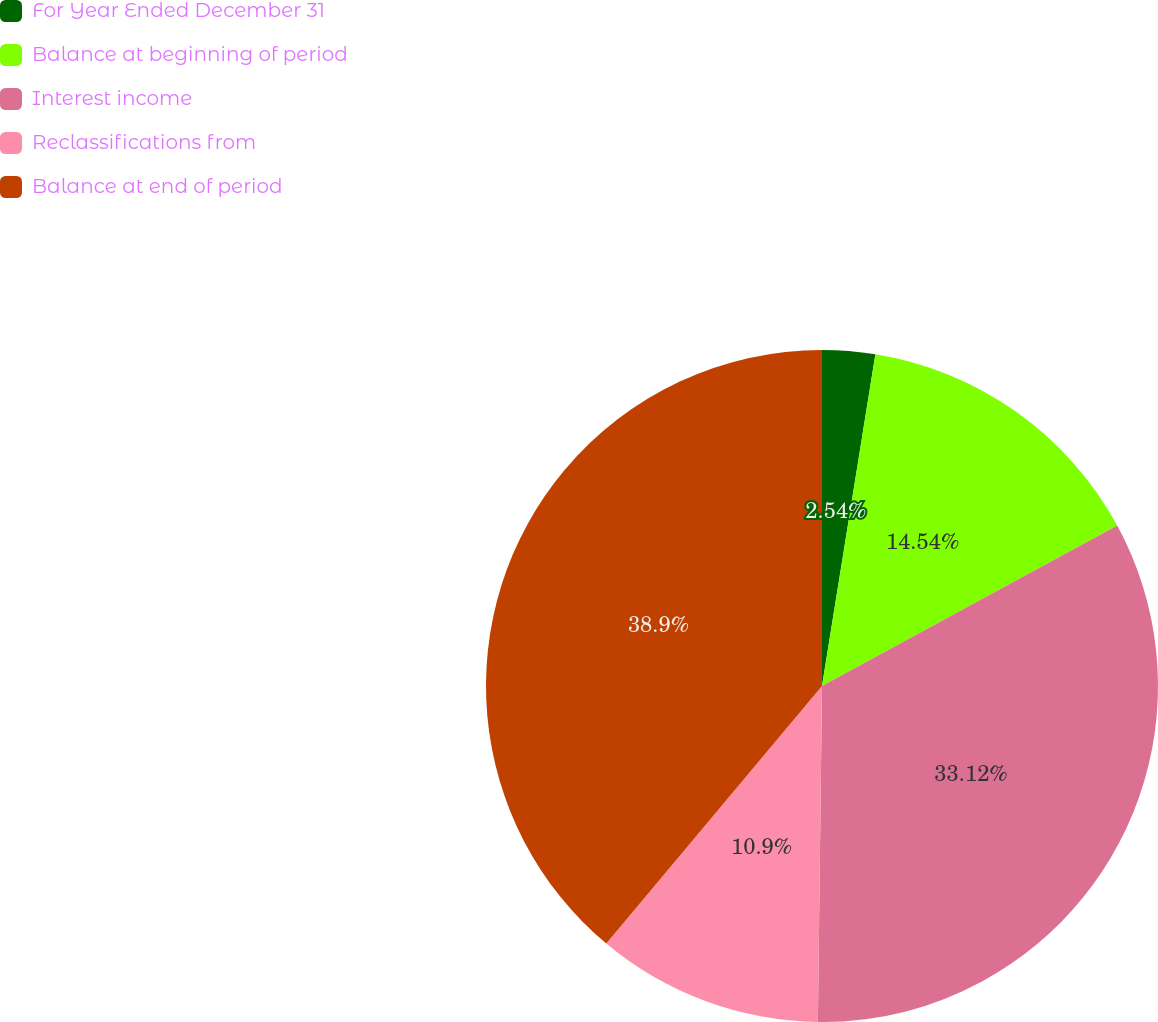Convert chart to OTSL. <chart><loc_0><loc_0><loc_500><loc_500><pie_chart><fcel>For Year Ended December 31<fcel>Balance at beginning of period<fcel>Interest income<fcel>Reclassifications from<fcel>Balance at end of period<nl><fcel>2.54%<fcel>14.54%<fcel>33.12%<fcel>10.9%<fcel>38.91%<nl></chart> 